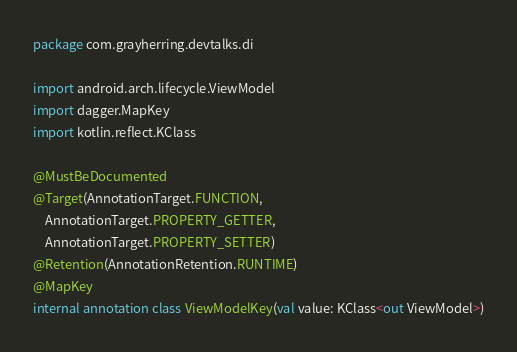<code> <loc_0><loc_0><loc_500><loc_500><_Kotlin_>package com.grayherring.devtalks.di

import android.arch.lifecycle.ViewModel
import dagger.MapKey
import kotlin.reflect.KClass

@MustBeDocumented
@Target(AnnotationTarget.FUNCTION,
    AnnotationTarget.PROPERTY_GETTER,
    AnnotationTarget.PROPERTY_SETTER)
@Retention(AnnotationRetention.RUNTIME)
@MapKey
internal annotation class ViewModelKey(val value: KClass<out ViewModel>)
</code> 